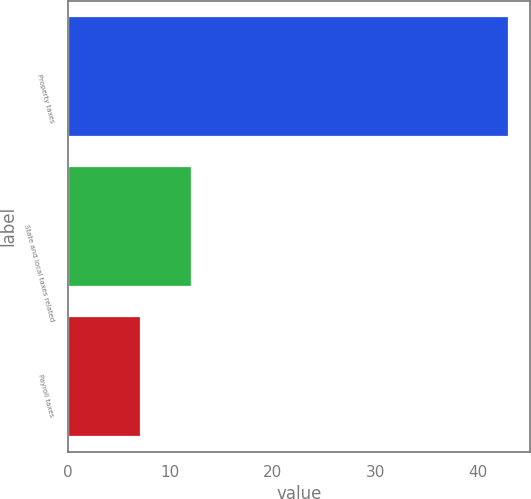<chart> <loc_0><loc_0><loc_500><loc_500><bar_chart><fcel>Property taxes<fcel>State and local taxes related<fcel>Payroll taxes<nl><fcel>43<fcel>12<fcel>7<nl></chart> 